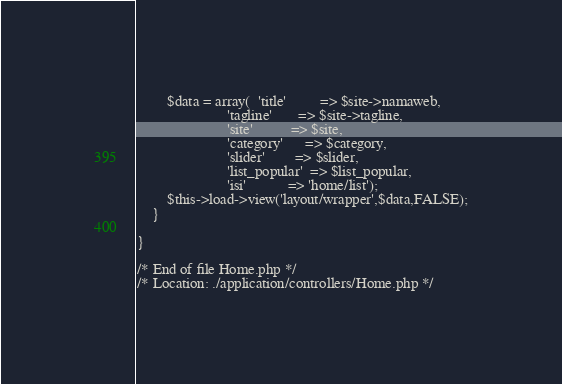<code> <loc_0><loc_0><loc_500><loc_500><_PHP_>
		$data = array(	'title' 		=> $site->namaweb,
						'tagline'		=> $site->tagline,
						'site'			=> $site,
						'category'		=> $category,
						'slider'		=> $slider,
						'list_popular'	=> $list_popular,
						'isi'			=> 'home/list'); 
		$this->load->view('layout/wrapper',$data,FALSE);
	}

}

/* End of file Home.php */
/* Location: ./application/controllers/Home.php */</code> 